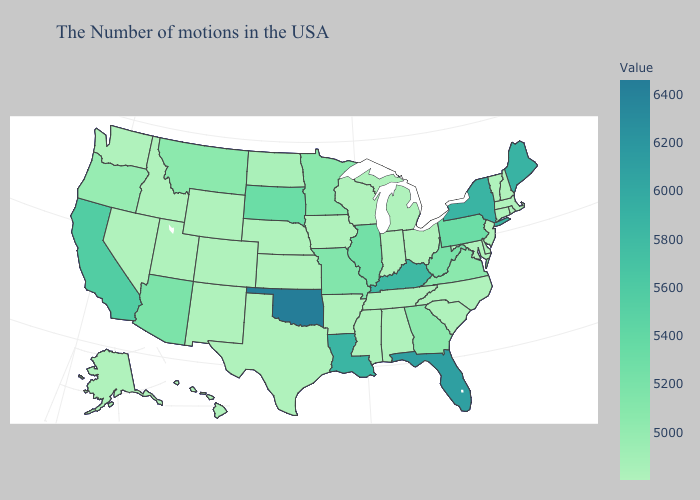Which states have the highest value in the USA?
Give a very brief answer. Oklahoma. Which states have the lowest value in the West?
Write a very short answer. Wyoming, Colorado, New Mexico, Utah, Idaho, Nevada, Washington, Alaska, Hawaii. Does Oregon have the lowest value in the USA?
Quick response, please. No. Which states have the highest value in the USA?
Answer briefly. Oklahoma. Is the legend a continuous bar?
Concise answer only. Yes. Among the states that border Wyoming , does Montana have the lowest value?
Answer briefly. No. Which states have the highest value in the USA?
Quick response, please. Oklahoma. 